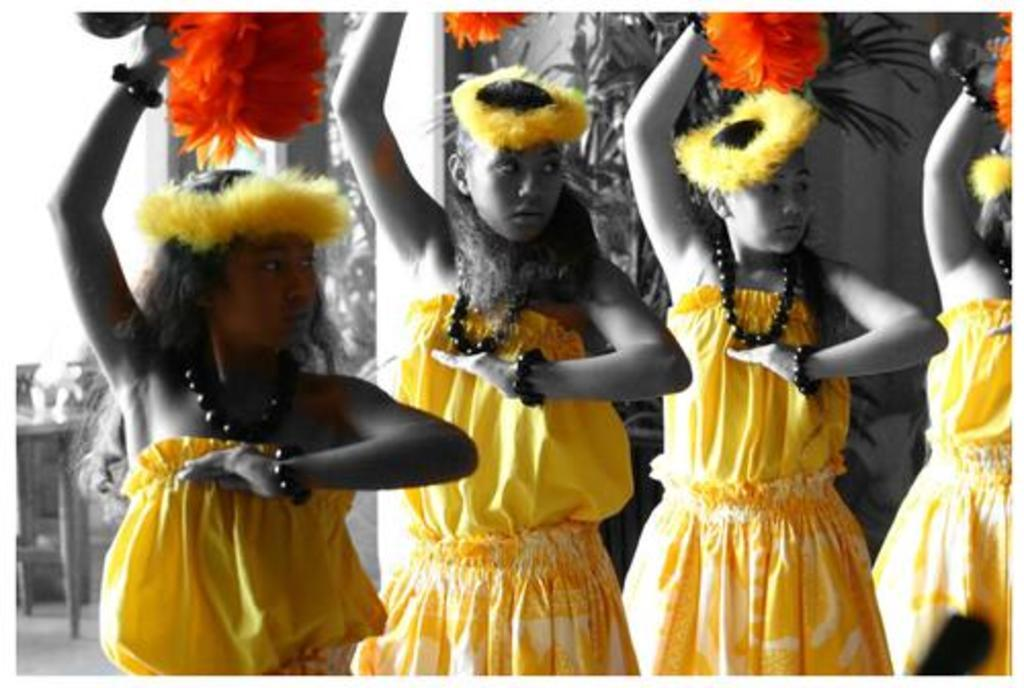How many people are in the image? There are four people standing in the center of the image. What are the people wearing? The people are wearing the same costumes. What can be seen on the left side of the image? There is a table on the left side of the image. What is visible in the background of the image? There is a wall and plants visible in the background of the image. What line do the people in the image believe in? There is no mention of a line or belief system in the image; it simply shows four people wearing the same costumes. 